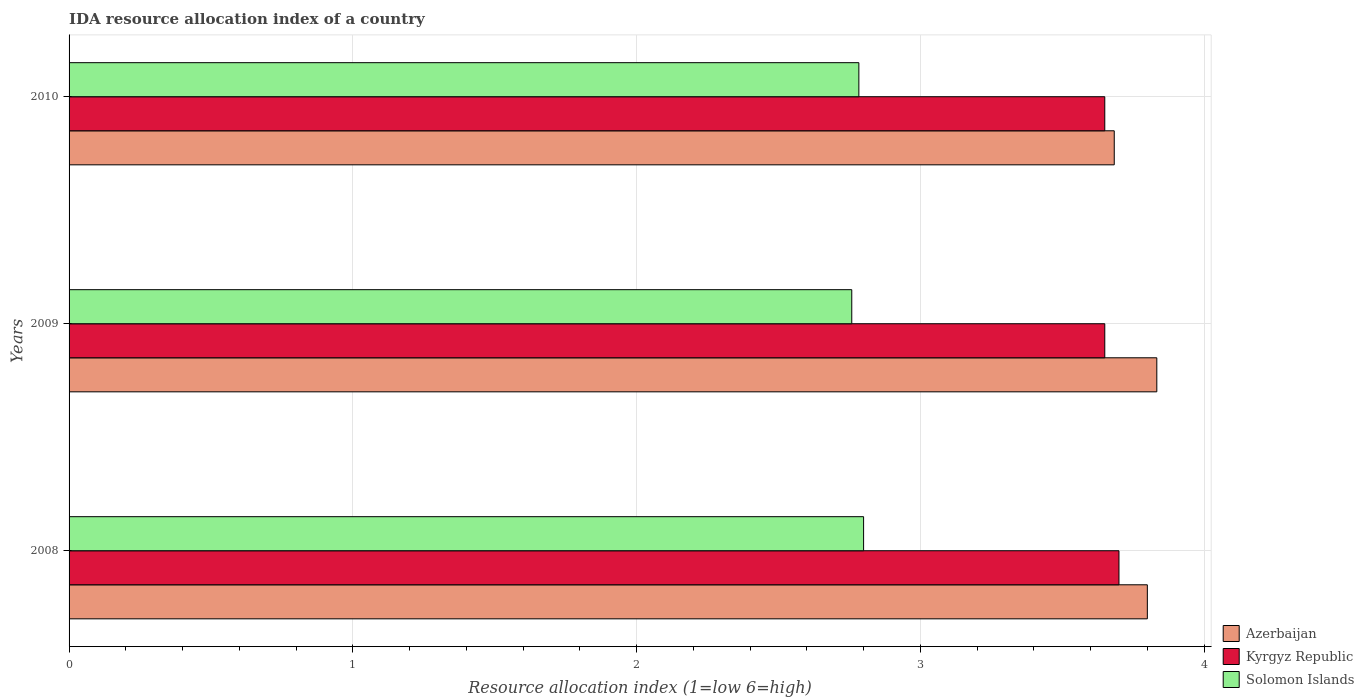How many groups of bars are there?
Your response must be concise. 3. How many bars are there on the 1st tick from the top?
Provide a succinct answer. 3. How many bars are there on the 2nd tick from the bottom?
Ensure brevity in your answer.  3. What is the IDA resource allocation index in Solomon Islands in 2009?
Your answer should be very brief. 2.76. Across all years, what is the maximum IDA resource allocation index in Azerbaijan?
Your response must be concise. 3.83. Across all years, what is the minimum IDA resource allocation index in Solomon Islands?
Make the answer very short. 2.76. In which year was the IDA resource allocation index in Solomon Islands maximum?
Your response must be concise. 2008. In which year was the IDA resource allocation index in Kyrgyz Republic minimum?
Make the answer very short. 2009. What is the total IDA resource allocation index in Solomon Islands in the graph?
Your answer should be compact. 8.34. What is the difference between the IDA resource allocation index in Solomon Islands in 2009 and that in 2010?
Your answer should be compact. -0.02. What is the difference between the IDA resource allocation index in Azerbaijan in 2009 and the IDA resource allocation index in Solomon Islands in 2008?
Offer a very short reply. 1.03. What is the average IDA resource allocation index in Azerbaijan per year?
Your answer should be compact. 3.77. In the year 2009, what is the difference between the IDA resource allocation index in Kyrgyz Republic and IDA resource allocation index in Solomon Islands?
Your answer should be very brief. 0.89. What is the ratio of the IDA resource allocation index in Kyrgyz Republic in 2008 to that in 2010?
Keep it short and to the point. 1.01. What is the difference between the highest and the second highest IDA resource allocation index in Solomon Islands?
Give a very brief answer. 0.02. What is the difference between the highest and the lowest IDA resource allocation index in Azerbaijan?
Offer a very short reply. 0.15. What does the 3rd bar from the top in 2008 represents?
Your answer should be compact. Azerbaijan. What does the 3rd bar from the bottom in 2008 represents?
Your answer should be compact. Solomon Islands. Is it the case that in every year, the sum of the IDA resource allocation index in Kyrgyz Republic and IDA resource allocation index in Azerbaijan is greater than the IDA resource allocation index in Solomon Islands?
Give a very brief answer. Yes. How many bars are there?
Your response must be concise. 9. Are all the bars in the graph horizontal?
Offer a very short reply. Yes. How many years are there in the graph?
Provide a short and direct response. 3. Are the values on the major ticks of X-axis written in scientific E-notation?
Ensure brevity in your answer.  No. Does the graph contain grids?
Your answer should be compact. Yes. Where does the legend appear in the graph?
Provide a succinct answer. Bottom right. How many legend labels are there?
Your answer should be compact. 3. What is the title of the graph?
Your answer should be compact. IDA resource allocation index of a country. What is the label or title of the X-axis?
Give a very brief answer. Resource allocation index (1=low 6=high). What is the label or title of the Y-axis?
Your answer should be very brief. Years. What is the Resource allocation index (1=low 6=high) of Kyrgyz Republic in 2008?
Provide a short and direct response. 3.7. What is the Resource allocation index (1=low 6=high) of Solomon Islands in 2008?
Provide a short and direct response. 2.8. What is the Resource allocation index (1=low 6=high) in Azerbaijan in 2009?
Keep it short and to the point. 3.83. What is the Resource allocation index (1=low 6=high) in Kyrgyz Republic in 2009?
Your response must be concise. 3.65. What is the Resource allocation index (1=low 6=high) of Solomon Islands in 2009?
Provide a short and direct response. 2.76. What is the Resource allocation index (1=low 6=high) in Azerbaijan in 2010?
Provide a short and direct response. 3.68. What is the Resource allocation index (1=low 6=high) in Kyrgyz Republic in 2010?
Your answer should be very brief. 3.65. What is the Resource allocation index (1=low 6=high) in Solomon Islands in 2010?
Ensure brevity in your answer.  2.78. Across all years, what is the maximum Resource allocation index (1=low 6=high) of Azerbaijan?
Your answer should be compact. 3.83. Across all years, what is the maximum Resource allocation index (1=low 6=high) of Kyrgyz Republic?
Give a very brief answer. 3.7. Across all years, what is the maximum Resource allocation index (1=low 6=high) in Solomon Islands?
Offer a terse response. 2.8. Across all years, what is the minimum Resource allocation index (1=low 6=high) in Azerbaijan?
Your response must be concise. 3.68. Across all years, what is the minimum Resource allocation index (1=low 6=high) in Kyrgyz Republic?
Your answer should be very brief. 3.65. Across all years, what is the minimum Resource allocation index (1=low 6=high) of Solomon Islands?
Offer a terse response. 2.76. What is the total Resource allocation index (1=low 6=high) of Azerbaijan in the graph?
Your answer should be very brief. 11.32. What is the total Resource allocation index (1=low 6=high) in Kyrgyz Republic in the graph?
Ensure brevity in your answer.  11. What is the total Resource allocation index (1=low 6=high) in Solomon Islands in the graph?
Provide a short and direct response. 8.34. What is the difference between the Resource allocation index (1=low 6=high) in Azerbaijan in 2008 and that in 2009?
Keep it short and to the point. -0.03. What is the difference between the Resource allocation index (1=low 6=high) in Solomon Islands in 2008 and that in 2009?
Provide a succinct answer. 0.04. What is the difference between the Resource allocation index (1=low 6=high) of Azerbaijan in 2008 and that in 2010?
Offer a very short reply. 0.12. What is the difference between the Resource allocation index (1=low 6=high) in Solomon Islands in 2008 and that in 2010?
Ensure brevity in your answer.  0.02. What is the difference between the Resource allocation index (1=low 6=high) in Kyrgyz Republic in 2009 and that in 2010?
Ensure brevity in your answer.  0. What is the difference between the Resource allocation index (1=low 6=high) in Solomon Islands in 2009 and that in 2010?
Offer a terse response. -0.03. What is the difference between the Resource allocation index (1=low 6=high) in Azerbaijan in 2008 and the Resource allocation index (1=low 6=high) in Solomon Islands in 2009?
Ensure brevity in your answer.  1.04. What is the difference between the Resource allocation index (1=low 6=high) in Kyrgyz Republic in 2008 and the Resource allocation index (1=low 6=high) in Solomon Islands in 2009?
Provide a short and direct response. 0.94. What is the difference between the Resource allocation index (1=low 6=high) of Azerbaijan in 2008 and the Resource allocation index (1=low 6=high) of Solomon Islands in 2010?
Provide a short and direct response. 1.02. What is the difference between the Resource allocation index (1=low 6=high) in Azerbaijan in 2009 and the Resource allocation index (1=low 6=high) in Kyrgyz Republic in 2010?
Ensure brevity in your answer.  0.18. What is the difference between the Resource allocation index (1=low 6=high) of Azerbaijan in 2009 and the Resource allocation index (1=low 6=high) of Solomon Islands in 2010?
Provide a succinct answer. 1.05. What is the difference between the Resource allocation index (1=low 6=high) of Kyrgyz Republic in 2009 and the Resource allocation index (1=low 6=high) of Solomon Islands in 2010?
Give a very brief answer. 0.87. What is the average Resource allocation index (1=low 6=high) of Azerbaijan per year?
Offer a very short reply. 3.77. What is the average Resource allocation index (1=low 6=high) in Kyrgyz Republic per year?
Give a very brief answer. 3.67. What is the average Resource allocation index (1=low 6=high) in Solomon Islands per year?
Your response must be concise. 2.78. In the year 2008, what is the difference between the Resource allocation index (1=low 6=high) in Azerbaijan and Resource allocation index (1=low 6=high) in Kyrgyz Republic?
Provide a succinct answer. 0.1. In the year 2008, what is the difference between the Resource allocation index (1=low 6=high) in Azerbaijan and Resource allocation index (1=low 6=high) in Solomon Islands?
Offer a very short reply. 1. In the year 2008, what is the difference between the Resource allocation index (1=low 6=high) in Kyrgyz Republic and Resource allocation index (1=low 6=high) in Solomon Islands?
Make the answer very short. 0.9. In the year 2009, what is the difference between the Resource allocation index (1=low 6=high) of Azerbaijan and Resource allocation index (1=low 6=high) of Kyrgyz Republic?
Give a very brief answer. 0.18. In the year 2009, what is the difference between the Resource allocation index (1=low 6=high) of Azerbaijan and Resource allocation index (1=low 6=high) of Solomon Islands?
Keep it short and to the point. 1.07. In the year 2009, what is the difference between the Resource allocation index (1=low 6=high) in Kyrgyz Republic and Resource allocation index (1=low 6=high) in Solomon Islands?
Provide a short and direct response. 0.89. In the year 2010, what is the difference between the Resource allocation index (1=low 6=high) in Kyrgyz Republic and Resource allocation index (1=low 6=high) in Solomon Islands?
Provide a succinct answer. 0.87. What is the ratio of the Resource allocation index (1=low 6=high) in Kyrgyz Republic in 2008 to that in 2009?
Keep it short and to the point. 1.01. What is the ratio of the Resource allocation index (1=low 6=high) in Solomon Islands in 2008 to that in 2009?
Your answer should be compact. 1.02. What is the ratio of the Resource allocation index (1=low 6=high) in Azerbaijan in 2008 to that in 2010?
Your answer should be compact. 1.03. What is the ratio of the Resource allocation index (1=low 6=high) in Kyrgyz Republic in 2008 to that in 2010?
Ensure brevity in your answer.  1.01. What is the ratio of the Resource allocation index (1=low 6=high) in Solomon Islands in 2008 to that in 2010?
Offer a very short reply. 1.01. What is the ratio of the Resource allocation index (1=low 6=high) in Azerbaijan in 2009 to that in 2010?
Offer a very short reply. 1.04. What is the ratio of the Resource allocation index (1=low 6=high) of Kyrgyz Republic in 2009 to that in 2010?
Give a very brief answer. 1. What is the difference between the highest and the second highest Resource allocation index (1=low 6=high) of Kyrgyz Republic?
Your answer should be very brief. 0.05. What is the difference between the highest and the second highest Resource allocation index (1=low 6=high) in Solomon Islands?
Provide a succinct answer. 0.02. What is the difference between the highest and the lowest Resource allocation index (1=low 6=high) of Azerbaijan?
Give a very brief answer. 0.15. What is the difference between the highest and the lowest Resource allocation index (1=low 6=high) of Kyrgyz Republic?
Your answer should be very brief. 0.05. What is the difference between the highest and the lowest Resource allocation index (1=low 6=high) of Solomon Islands?
Keep it short and to the point. 0.04. 